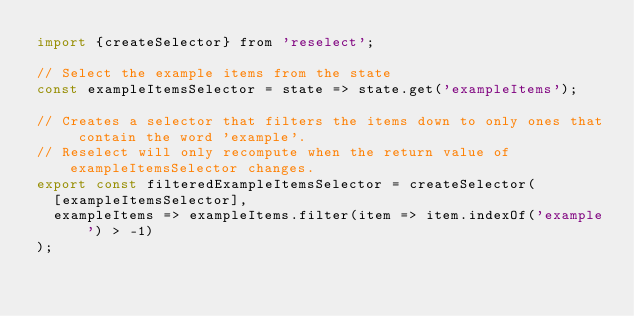Convert code to text. <code><loc_0><loc_0><loc_500><loc_500><_JavaScript_>import {createSelector} from 'reselect';

// Select the example items from the state
const exampleItemsSelector = state => state.get('exampleItems');

// Creates a selector that filters the items down to only ones that contain the word 'example'.
// Reselect will only recompute when the return value of exampleItemsSelector changes.
export const filteredExampleItemsSelector = createSelector(
  [exampleItemsSelector],
  exampleItems => exampleItems.filter(item => item.indexOf('example') > -1)
);
</code> 